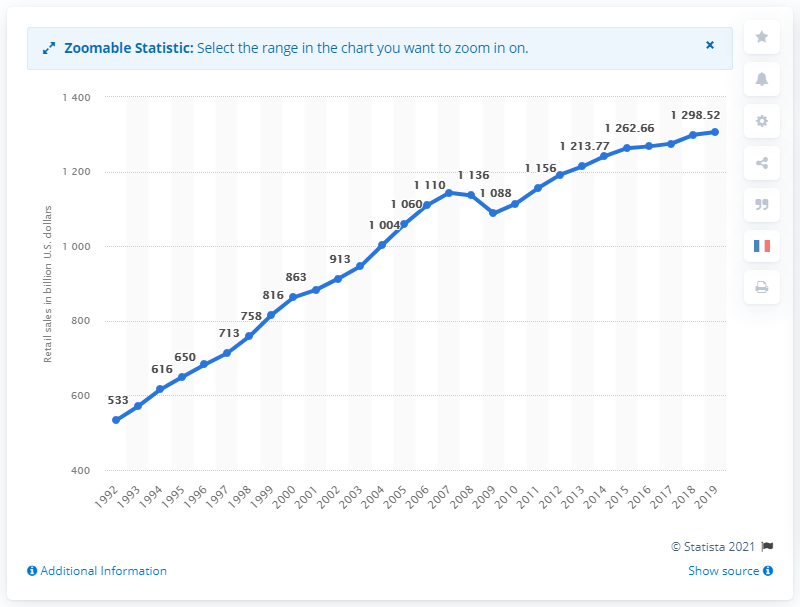Give some essential details in this illustration. In the United States in 2019, the total amount of GAFO sales was 1305.94 dollars. The GAFO sales in the United States a year earlier were 1298.52... 